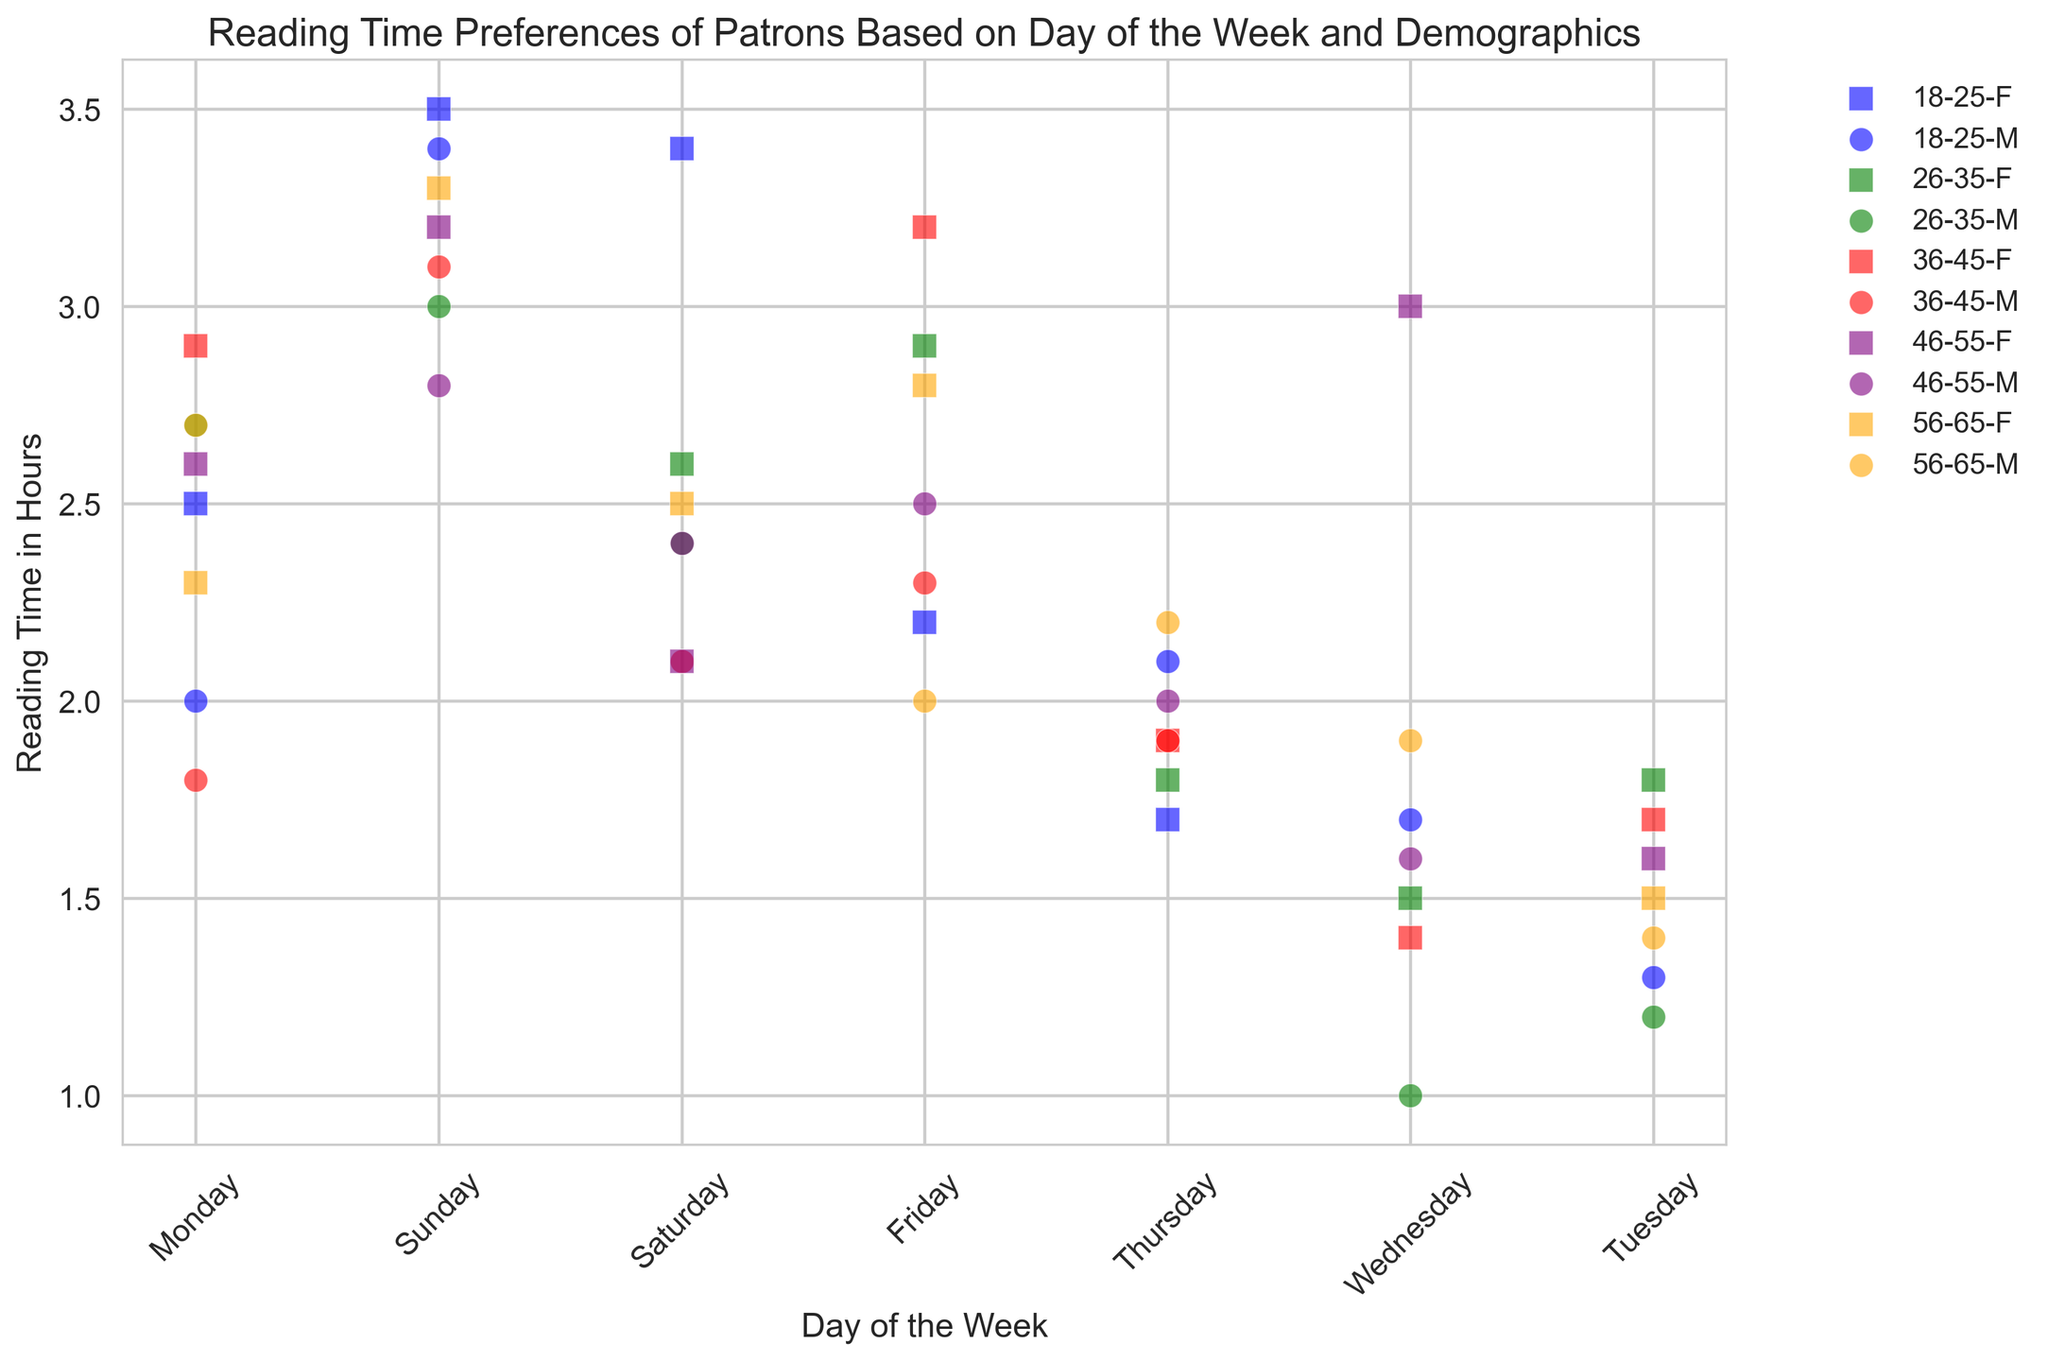What is the average reading time on Friday for the age group 36-45? To find the average reading time on Friday for the age group 36-45, look at the points representing the age group 36-45 and the day Friday. Sum their reading times and divide by the number of points. For Friday, there are two points: 3.2 and 2.3, so the average is (3.2 + 2.3) / 2.
Answer: 2.75 Which gender has a higher average reading time on Sunday for the age group 18-25? Locate the points for the age group 18-25 on Sunday. Compare the reading times between females and males. The reading times are 3.5 for females and 3.4 for males. The female group has a higher average reading time.
Answer: Female What is the difference in reading time between males and females on Monday in the age group 56-65? Find the points for Monday within the 56-65 age group for both genders. The reading times are 2.7 for males and 2.3 for females. Subtract 2.3 from 2.7 to get the difference.
Answer: 0.4 Which age group has the lowest average reading time on Wednesday? Look at the points representing Wednesday for each age group, then average the reading times within these age groups. Compare these averages. The values are: 18-25: 1.7, 26-35: 1.5, 36-45: 1.4, 46-55: 3.0, 56-65: 1.9. The age group 36-45 has the lowest average.
Answer: 36-45 Are there more males or females who read more than 3 hours on Saturday? Identify the points on the plot representing Saturday and check reading times above 3 hours. Count the number of males and females that meet this criterion. There is 1 female and 1 male, making it equal.
Answer: Equal Which day of the week has the most uniform reading time across all age groups? Evaluate the dispersion of reading times across all age groups for each day of the week by observing the spread of points on the y-axis. Sunday shows the most uniform distribution as it has close reading times for all age groups.
Answer: Sunday Which day shows the highest disparity in reading times for the 26-35 age group? Examine the points corresponding to the 26-35 age group on each weekday and note their spread on the y-axis. The day with the highest range or spread of values indicates the greatest disparity. Wednesday has reading times of 1.0 and 1.5, exhibiting the highest disparity.
Answer: Wednesday What do you observe about the reading times for males and females in the age group 46-55? Compare the relative positions of points for males and females within the 46-55 age group across different days. Generally, females have a higher reading time than males in most cases, except for Thursday and Friday where male reading time is slightly higher or the same.
Answer: Females generally higher 